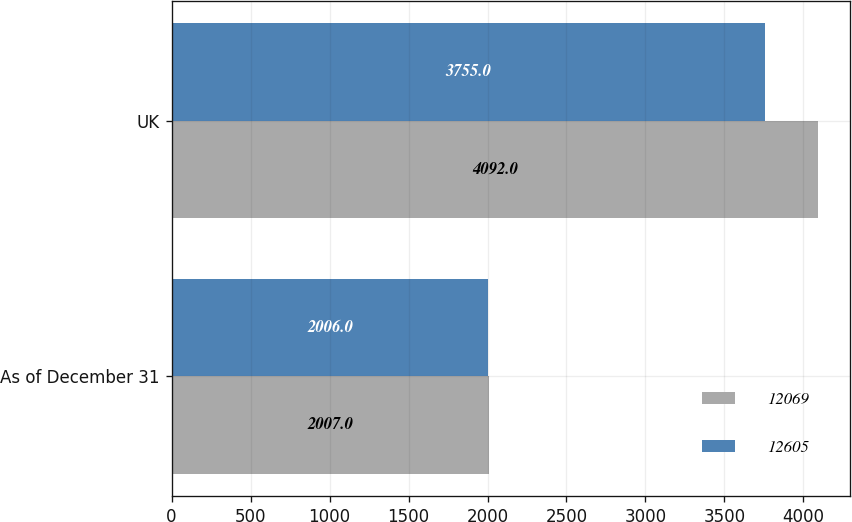Convert chart to OTSL. <chart><loc_0><loc_0><loc_500><loc_500><stacked_bar_chart><ecel><fcel>As of December 31<fcel>UK<nl><fcel>12069<fcel>2007<fcel>4092<nl><fcel>12605<fcel>2006<fcel>3755<nl></chart> 